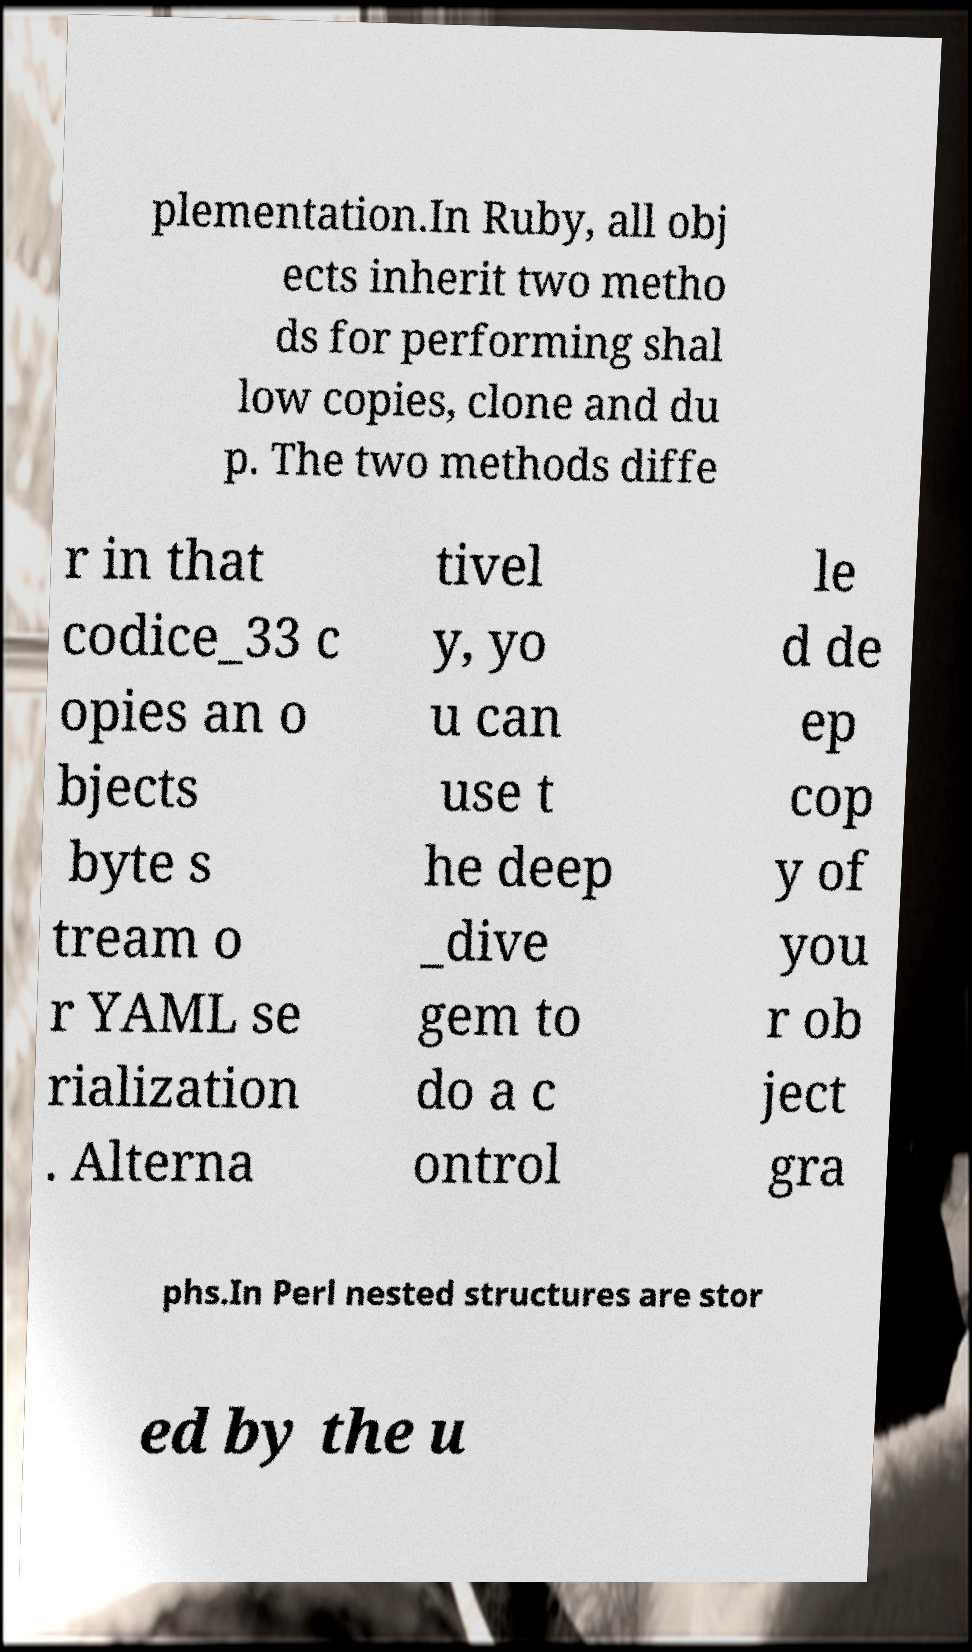Could you assist in decoding the text presented in this image and type it out clearly? plementation.In Ruby, all obj ects inherit two metho ds for performing shal low copies, clone and du p. The two methods diffe r in that codice_33 c opies an o bjects byte s tream o r YAML se rialization . Alterna tivel y, yo u can use t he deep _dive gem to do a c ontrol le d de ep cop y of you r ob ject gra phs.In Perl nested structures are stor ed by the u 